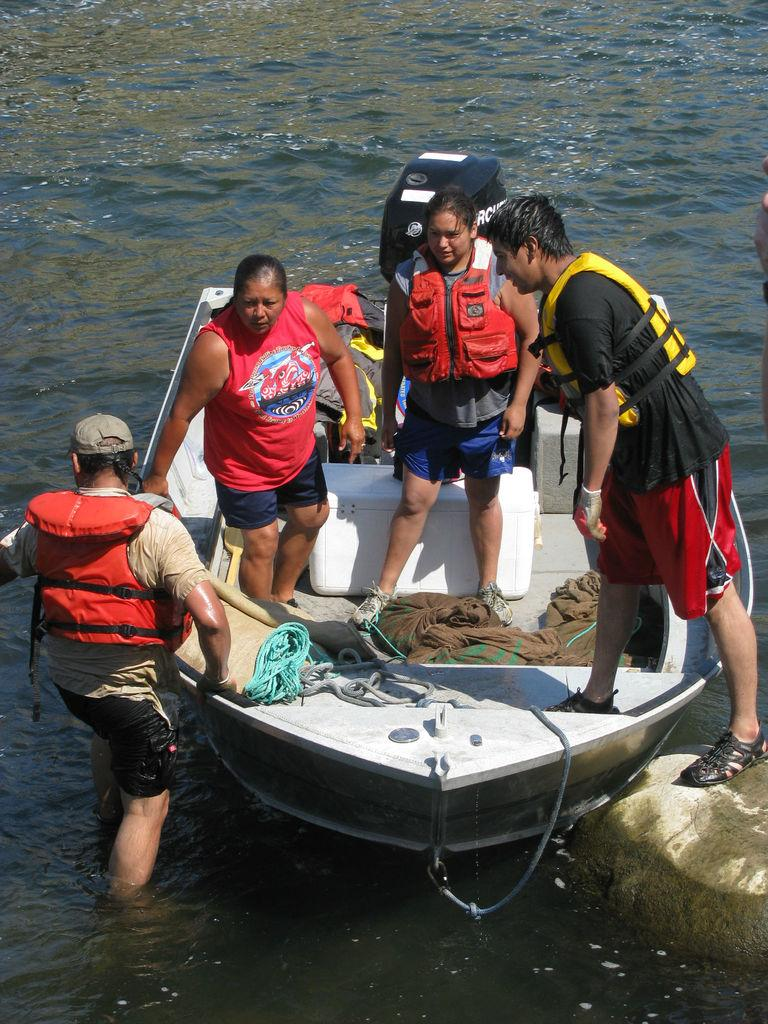What is happening in the image involving people? There are people standing in the image. What is the boat's position in relation to the water? The boat is above the water in the image. What are the ropes used for on the boat? Ropes are present on the boat, likely for tying or securing purposes. What else can be seen on the boat besides the ropes? Clothes are visible on the boat. How many grapes are being used to support the existence of wood in the image? There are no grapes or wood present in the image, so this question cannot be answered. 